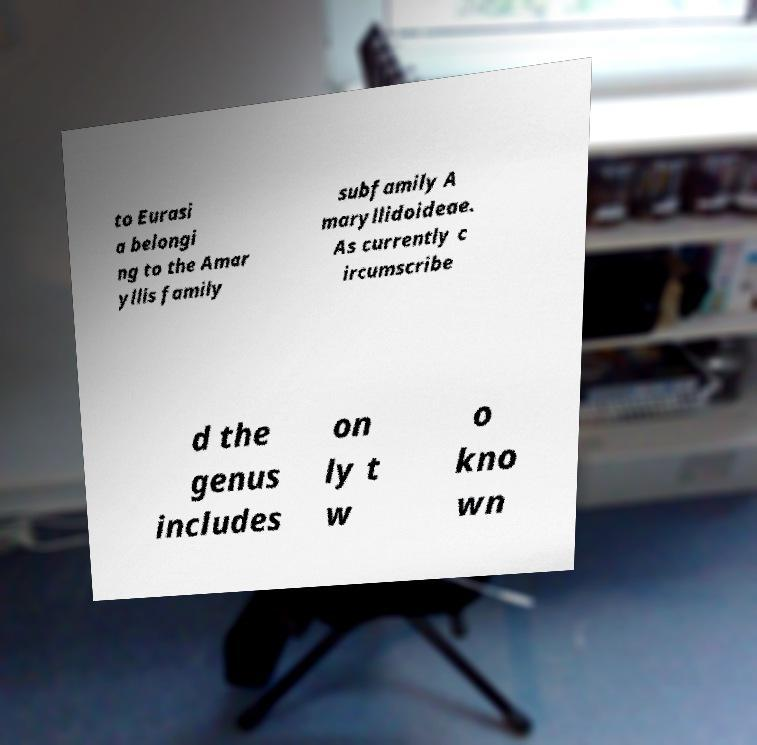What messages or text are displayed in this image? I need them in a readable, typed format. to Eurasi a belongi ng to the Amar yllis family subfamily A maryllidoideae. As currently c ircumscribe d the genus includes on ly t w o kno wn 